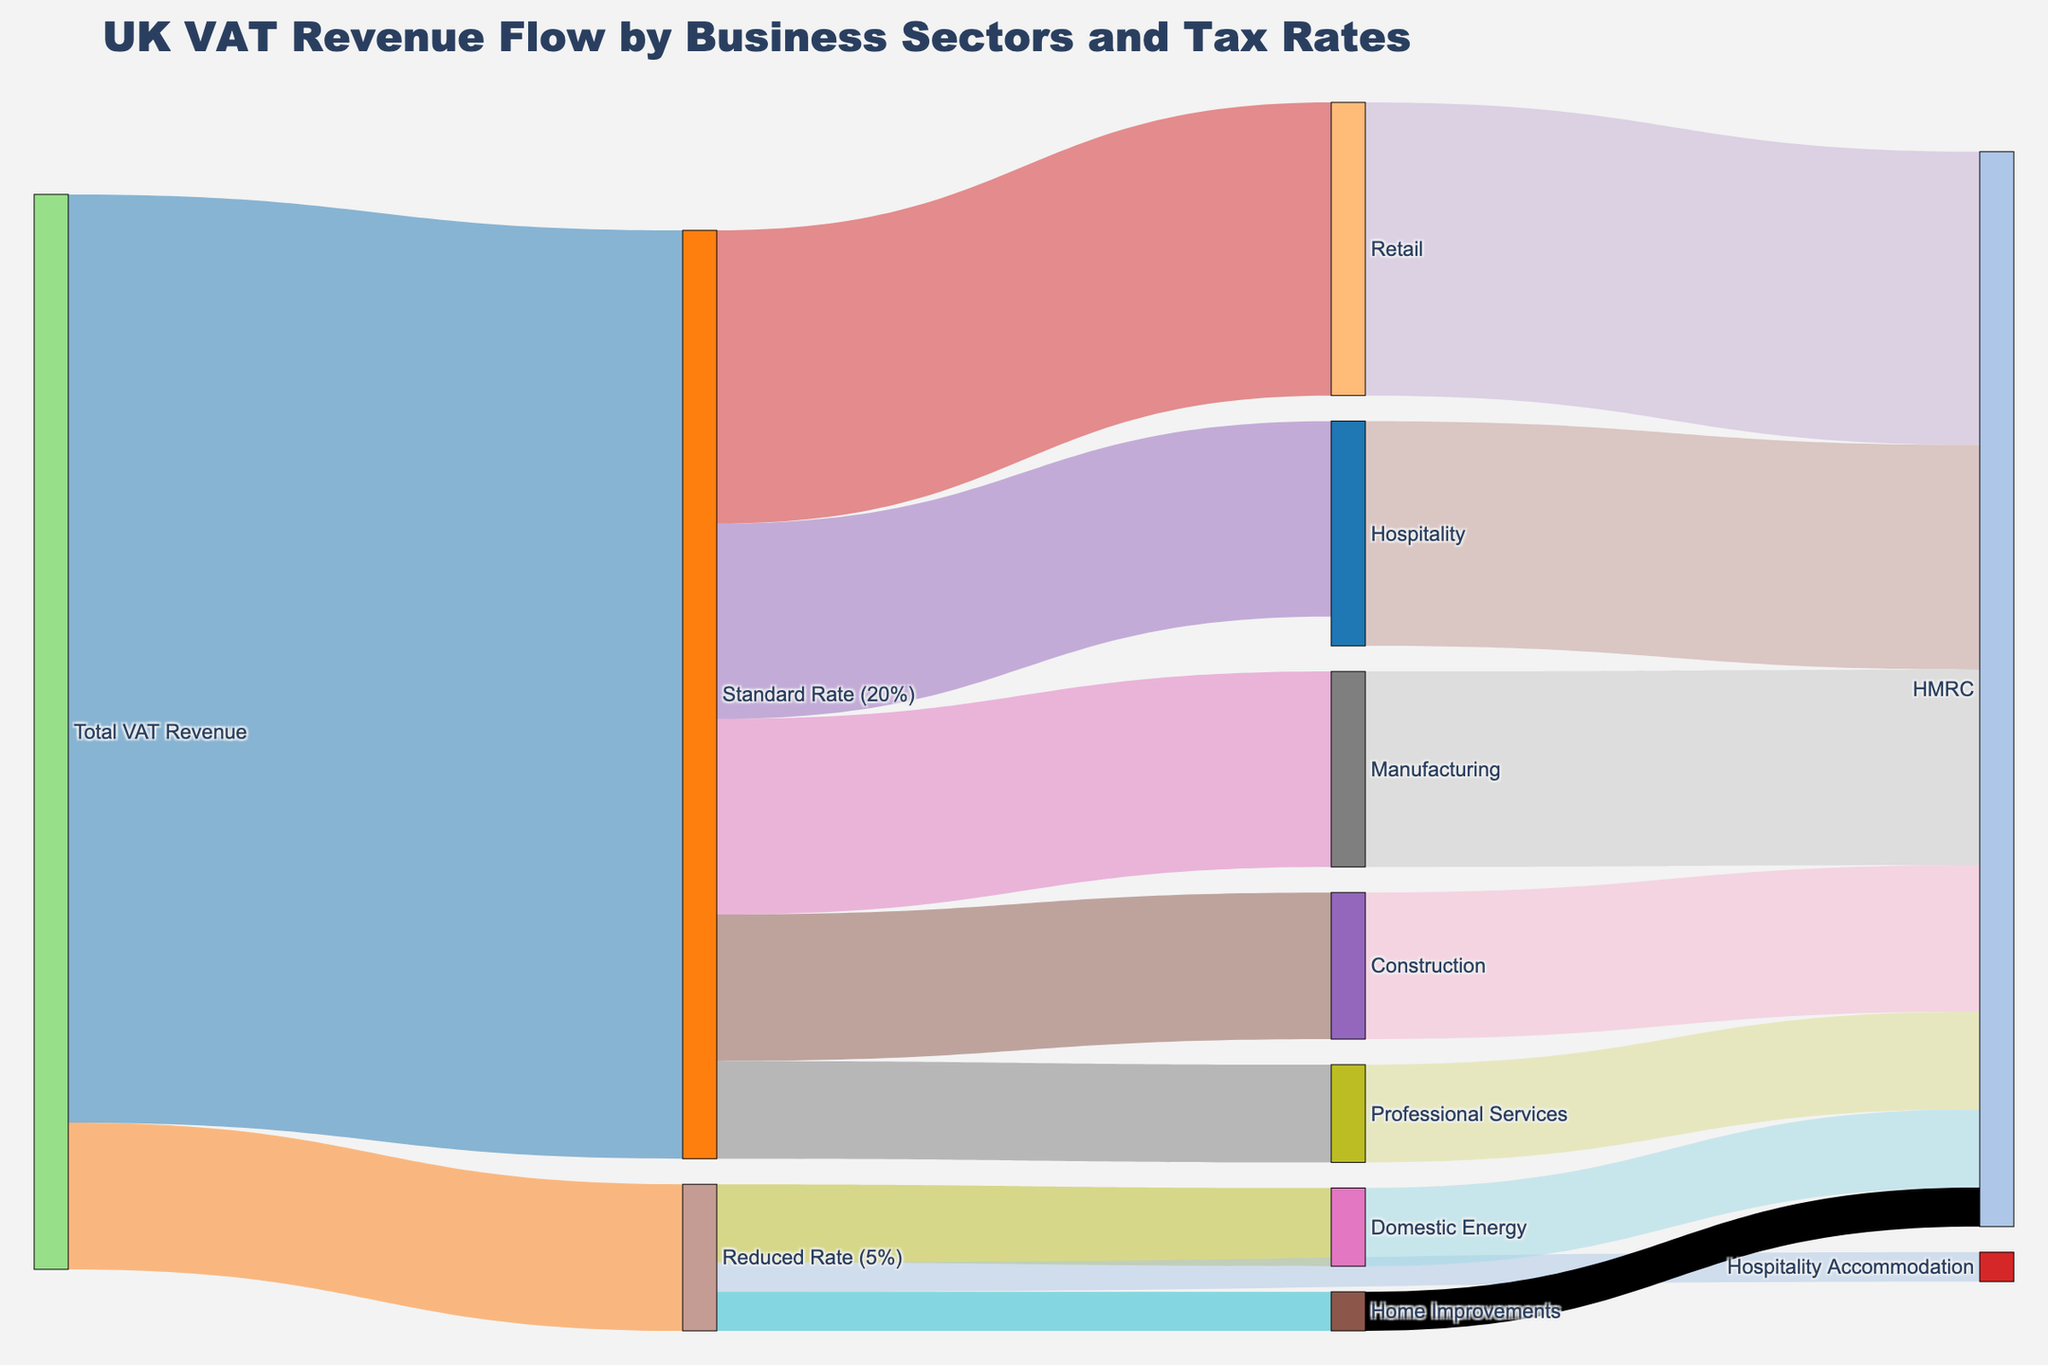What is the total value of VAT revenue at the Standard Rate? The total value of VAT at the Standard Rate can be found where "Total VAT Revenue" connects to "Standard Rate (20%)", which is 95000.
Answer: 95000 How much VAT revenue comes from the Hospitality sector? Look at the link between "Hospitality" and "HMRC". The flow value is 23000.
Answer: 23000 Which business sector contributes the highest VAT revenue under the Standard Rate? Among "Retail", "Hospitality", "Construction", "Manufacturing", and "Professional Services" under "Standard Rate (20%)", "Retail" has the highest value of 30000.
Answer: Retail How does the VAT revenue from Manufacturing compare to that from Construction? The value from Manufacturing to HMRC is 20000, whereas from Construction to HMRC it's 15000. Therefore, Manufacturing revenue is higher.
Answer: Manufacturing revenue is higher What is the combined VAT revenue from the Retail and Manufacturing sectors? Sum of values from "Retail" (30000) and "Manufacturing" (20000): 30000 + 20000 = 50000.
Answer: 50000 Which category at the Reduced Rate contributes the least to VAT revenue? Comparing "Domestic Energy" (8000), "Home Improvements" (4000), and "Hospitality Accommodation" (3000), "Hospitality Accommodation" contributes the least.
Answer: Hospitality Accommodation What is the total VAT revenue collected from all sectors? Add up all values ending at "HMRC": 30000 + 23000 + 15000 + 20000 + 10000 + 8000 + 4000. The values total 110000.
Answer: 110000 How many sectors have zero VAT revenue? "Food", "Books", and "Children's Clothing" under "Zero Rate (0%)" all have zero VAT revenue, so there are three.
Answer: Three What percentage of the VAT revenue comes from sectors under the Reduced Rate? Total Reduced Rate revenue is 15000. Total VAT revenue is 95000 + 15000 = 110000. The percentage is (15000 / 110000) * 100 ≈ 13.64%.
Answer: 13.64% What is the difference in VAT revenue between the Retail and Professional Services sectors? VAT revenue from Retail is 30000 and from Professional Services is 10000. The difference is 30000 - 10000 = 20000.
Answer: 20000 